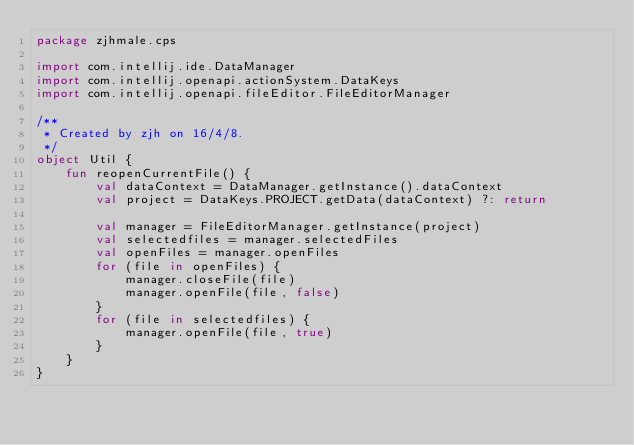Convert code to text. <code><loc_0><loc_0><loc_500><loc_500><_Kotlin_>package zjhmale.cps

import com.intellij.ide.DataManager
import com.intellij.openapi.actionSystem.DataKeys
import com.intellij.openapi.fileEditor.FileEditorManager

/**
 * Created by zjh on 16/4/8.
 */
object Util {
    fun reopenCurrentFile() {
        val dataContext = DataManager.getInstance().dataContext
        val project = DataKeys.PROJECT.getData(dataContext) ?: return

        val manager = FileEditorManager.getInstance(project)
        val selectedfiles = manager.selectedFiles
        val openFiles = manager.openFiles
        for (file in openFiles) {
            manager.closeFile(file)
            manager.openFile(file, false)
        }
        for (file in selectedfiles) {
            manager.openFile(file, true)
        }
    }
}</code> 